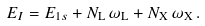<formula> <loc_0><loc_0><loc_500><loc_500>E _ { I } = E _ { 1 s } + N _ { \mathrm L } \, \omega _ { \mathrm L } + N _ { \mathrm X } \, \omega _ { \mathrm X } \, .</formula> 